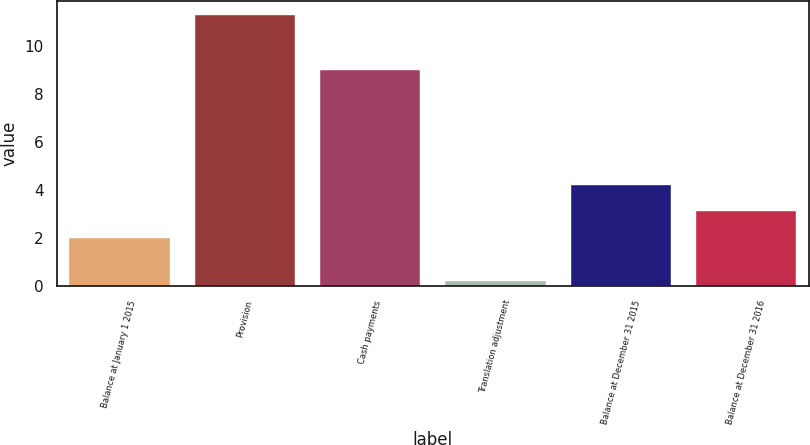Convert chart to OTSL. <chart><loc_0><loc_0><loc_500><loc_500><bar_chart><fcel>Balance at January 1 2015<fcel>Provision<fcel>Cash payments<fcel>Translation adjustment<fcel>Balance at December 31 2015<fcel>Balance at December 31 2016<nl><fcel>2<fcel>11.3<fcel>9<fcel>0.2<fcel>4.22<fcel>3.11<nl></chart> 